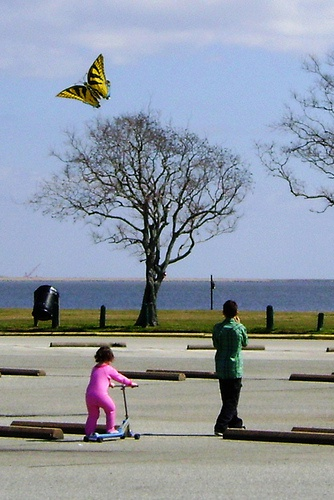Describe the objects in this image and their specific colors. I can see people in darkgray, black, green, teal, and darkgreen tones, people in darkgray, purple, violet, and black tones, and kite in darkgray, black, and olive tones in this image. 